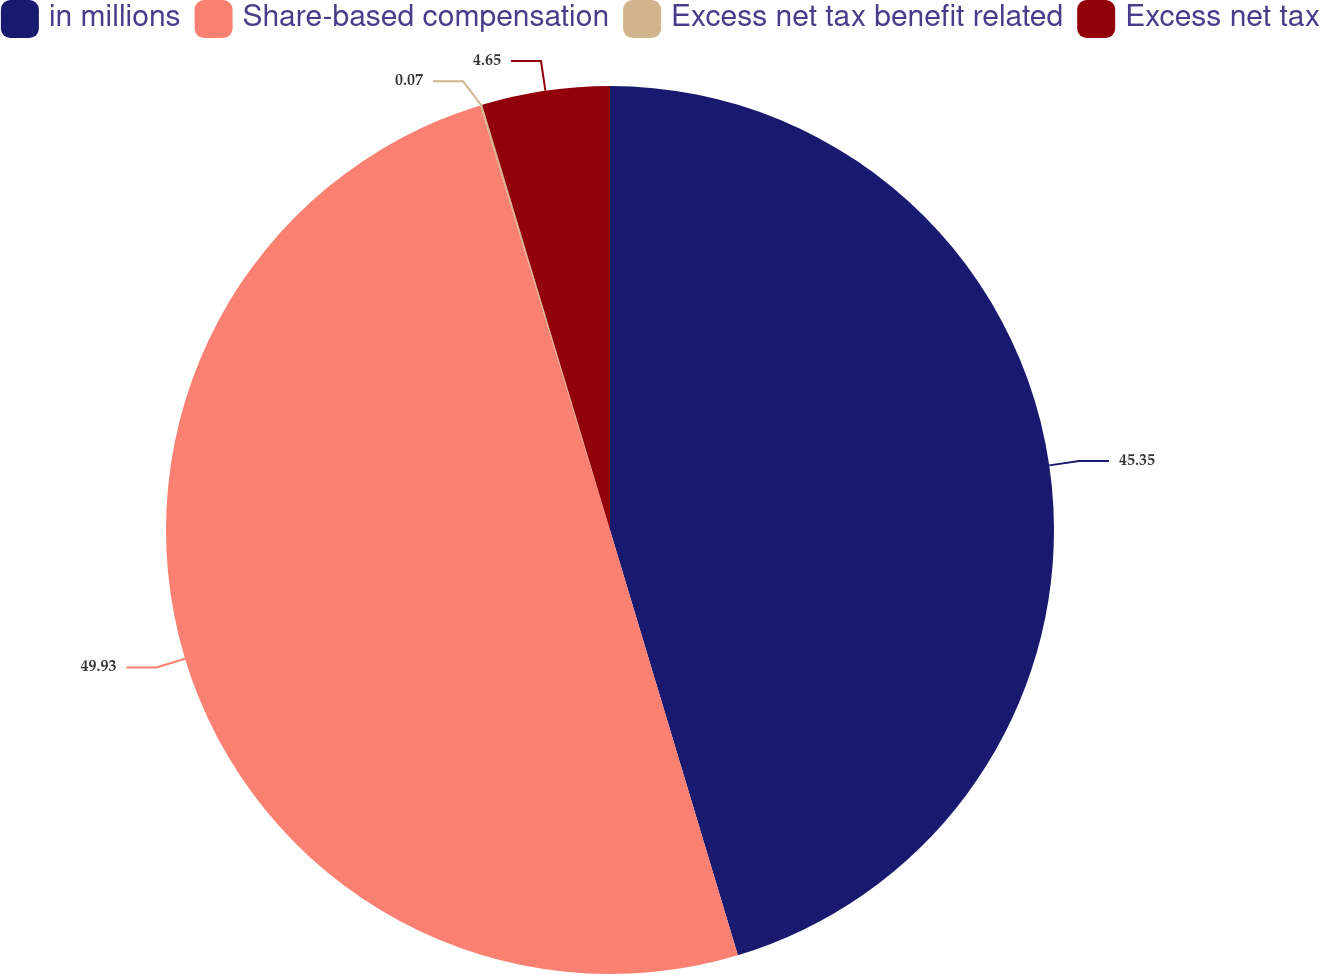Convert chart to OTSL. <chart><loc_0><loc_0><loc_500><loc_500><pie_chart><fcel>in millions<fcel>Share-based compensation<fcel>Excess net tax benefit related<fcel>Excess net tax<nl><fcel>45.35%<fcel>49.93%<fcel>0.07%<fcel>4.65%<nl></chart> 